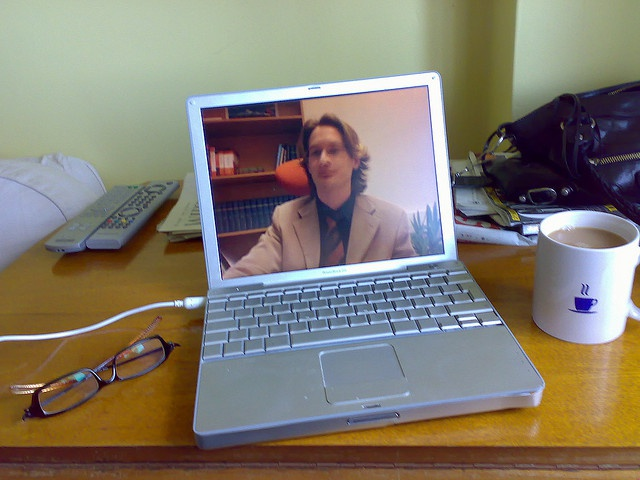Describe the objects in this image and their specific colors. I can see laptop in darkgray, lightslategray, gray, and lavender tones, handbag in lightgray, black, navy, gray, and blue tones, people in lightgray, gray, purple, darkgray, and navy tones, cup in lightgray, white, gray, and darkgray tones, and remote in lightgray, gray, and black tones in this image. 